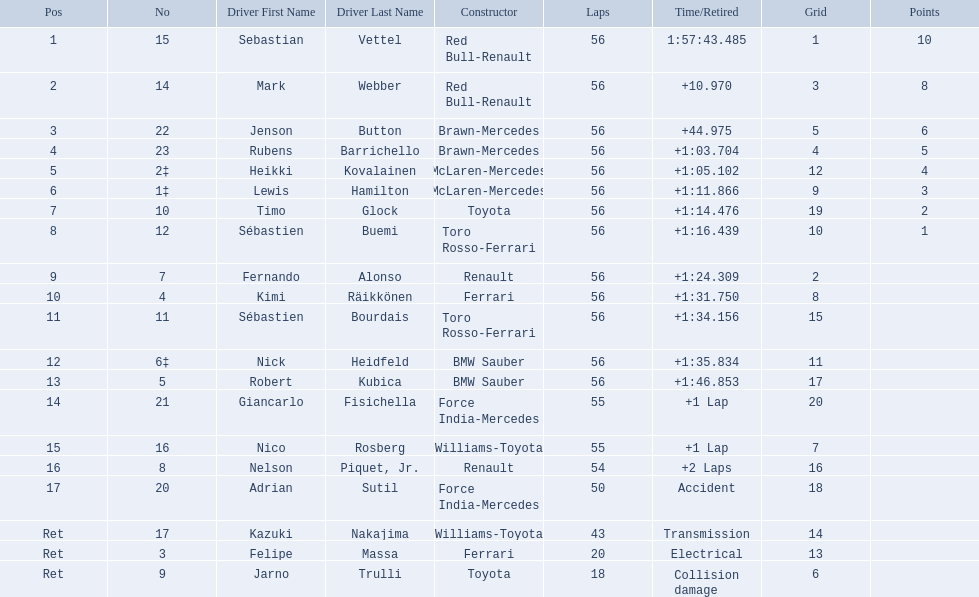Who were all of the drivers in the 2009 chinese grand prix? Sebastian Vettel, Mark Webber, Jenson Button, Rubens Barrichello, Heikki Kovalainen, Lewis Hamilton, Timo Glock, Sébastien Buemi, Fernando Alonso, Kimi Räikkönen, Sébastien Bourdais, Nick Heidfeld, Robert Kubica, Giancarlo Fisichella, Nico Rosberg, Nelson Piquet, Jr., Adrian Sutil, Kazuki Nakajima, Felipe Massa, Jarno Trulli. And what were their finishing times? 1:57:43.485, +10.970, +44.975, +1:03.704, +1:05.102, +1:11.866, +1:14.476, +1:16.439, +1:24.309, +1:31.750, +1:34.156, +1:35.834, +1:46.853, +1 Lap, +1 Lap, +2 Laps, Accident, Transmission, Electrical, Collision damage. Which player faced collision damage and retired from the race? Jarno Trulli. 